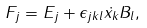<formula> <loc_0><loc_0><loc_500><loc_500>F _ { j } = E _ { j } + \epsilon _ { j k l } \dot { x _ { k } } B _ { l } ,</formula> 